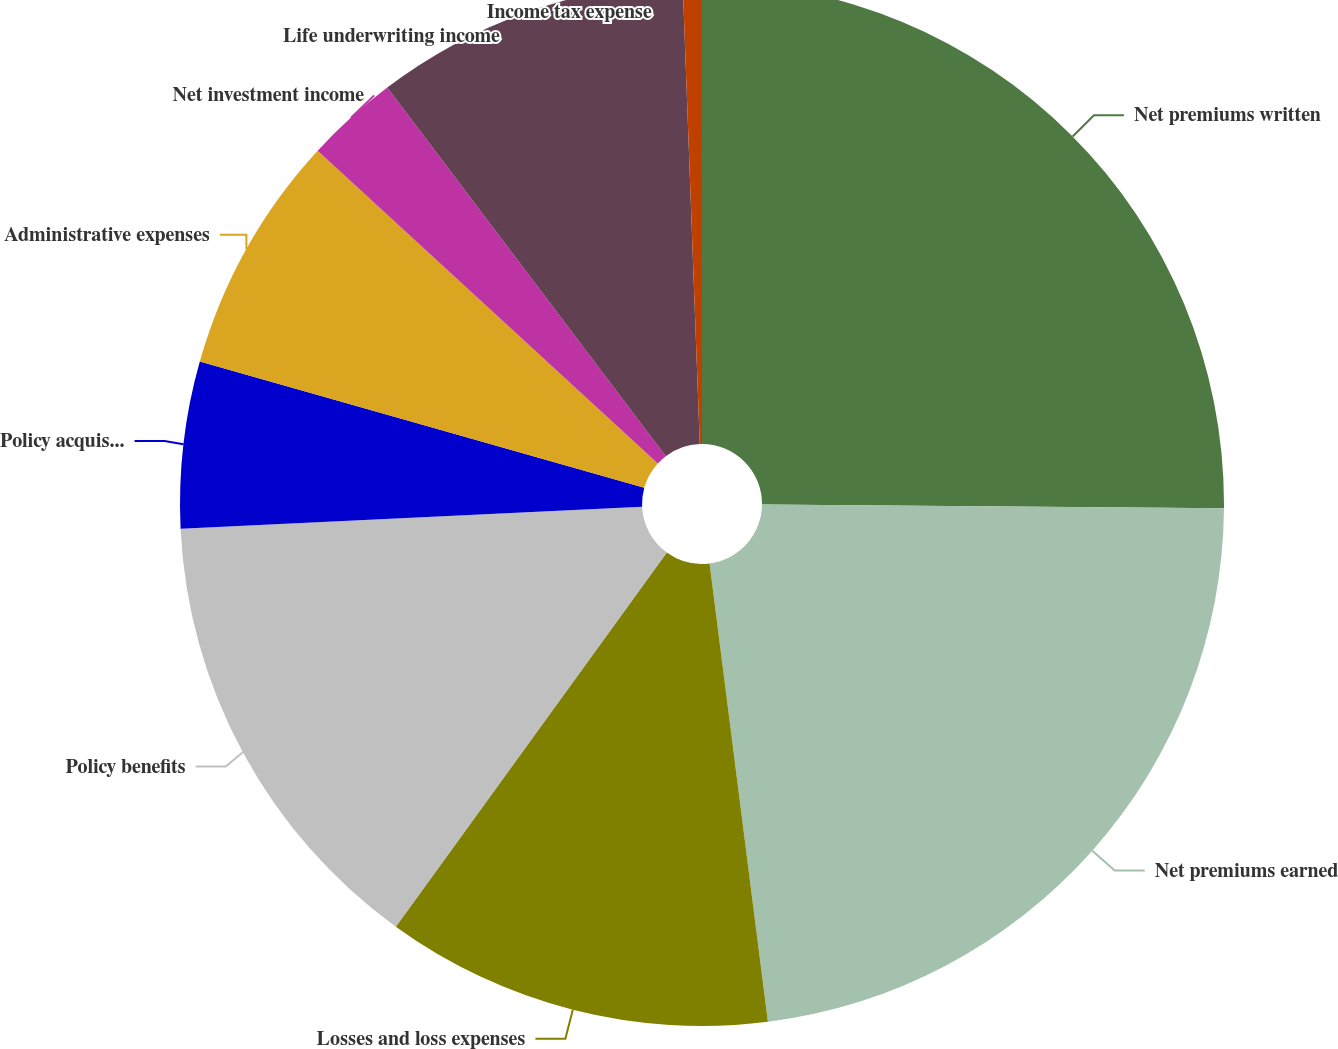<chart> <loc_0><loc_0><loc_500><loc_500><pie_chart><fcel>Net premiums written<fcel>Net premiums earned<fcel>Losses and loss expenses<fcel>Policy benefits<fcel>Policy acquisition costs<fcel>Administrative expenses<fcel>Net investment income<fcel>Life underwriting income<fcel>Income tax expense<nl><fcel>25.13%<fcel>22.85%<fcel>11.99%<fcel>14.27%<fcel>5.15%<fcel>7.43%<fcel>2.87%<fcel>9.71%<fcel>0.59%<nl></chart> 